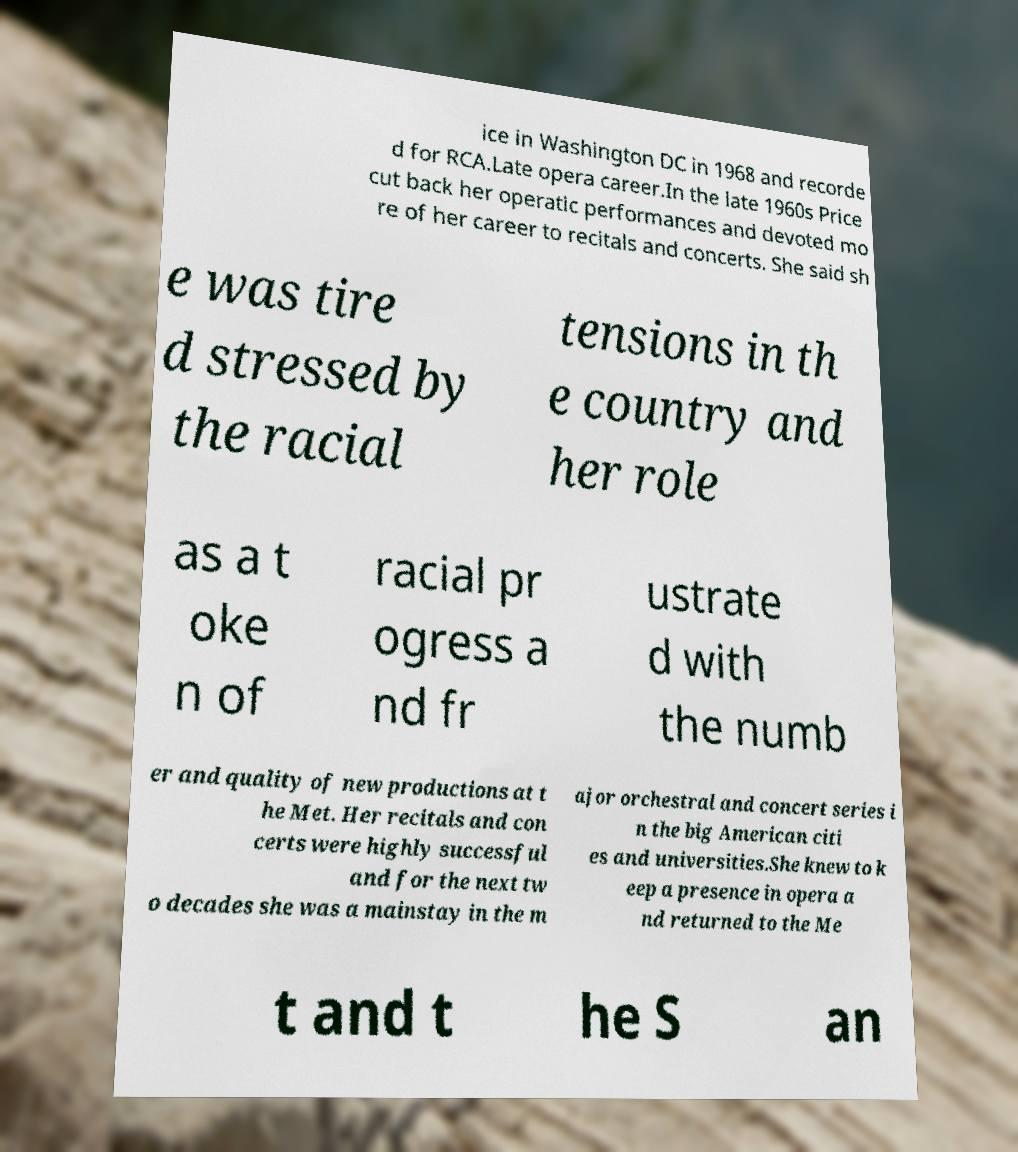What messages or text are displayed in this image? I need them in a readable, typed format. ice in Washington DC in 1968 and recorde d for RCA.Late opera career.In the late 1960s Price cut back her operatic performances and devoted mo re of her career to recitals and concerts. She said sh e was tire d stressed by the racial tensions in th e country and her role as a t oke n of racial pr ogress a nd fr ustrate d with the numb er and quality of new productions at t he Met. Her recitals and con certs were highly successful and for the next tw o decades she was a mainstay in the m ajor orchestral and concert series i n the big American citi es and universities.She knew to k eep a presence in opera a nd returned to the Me t and t he S an 